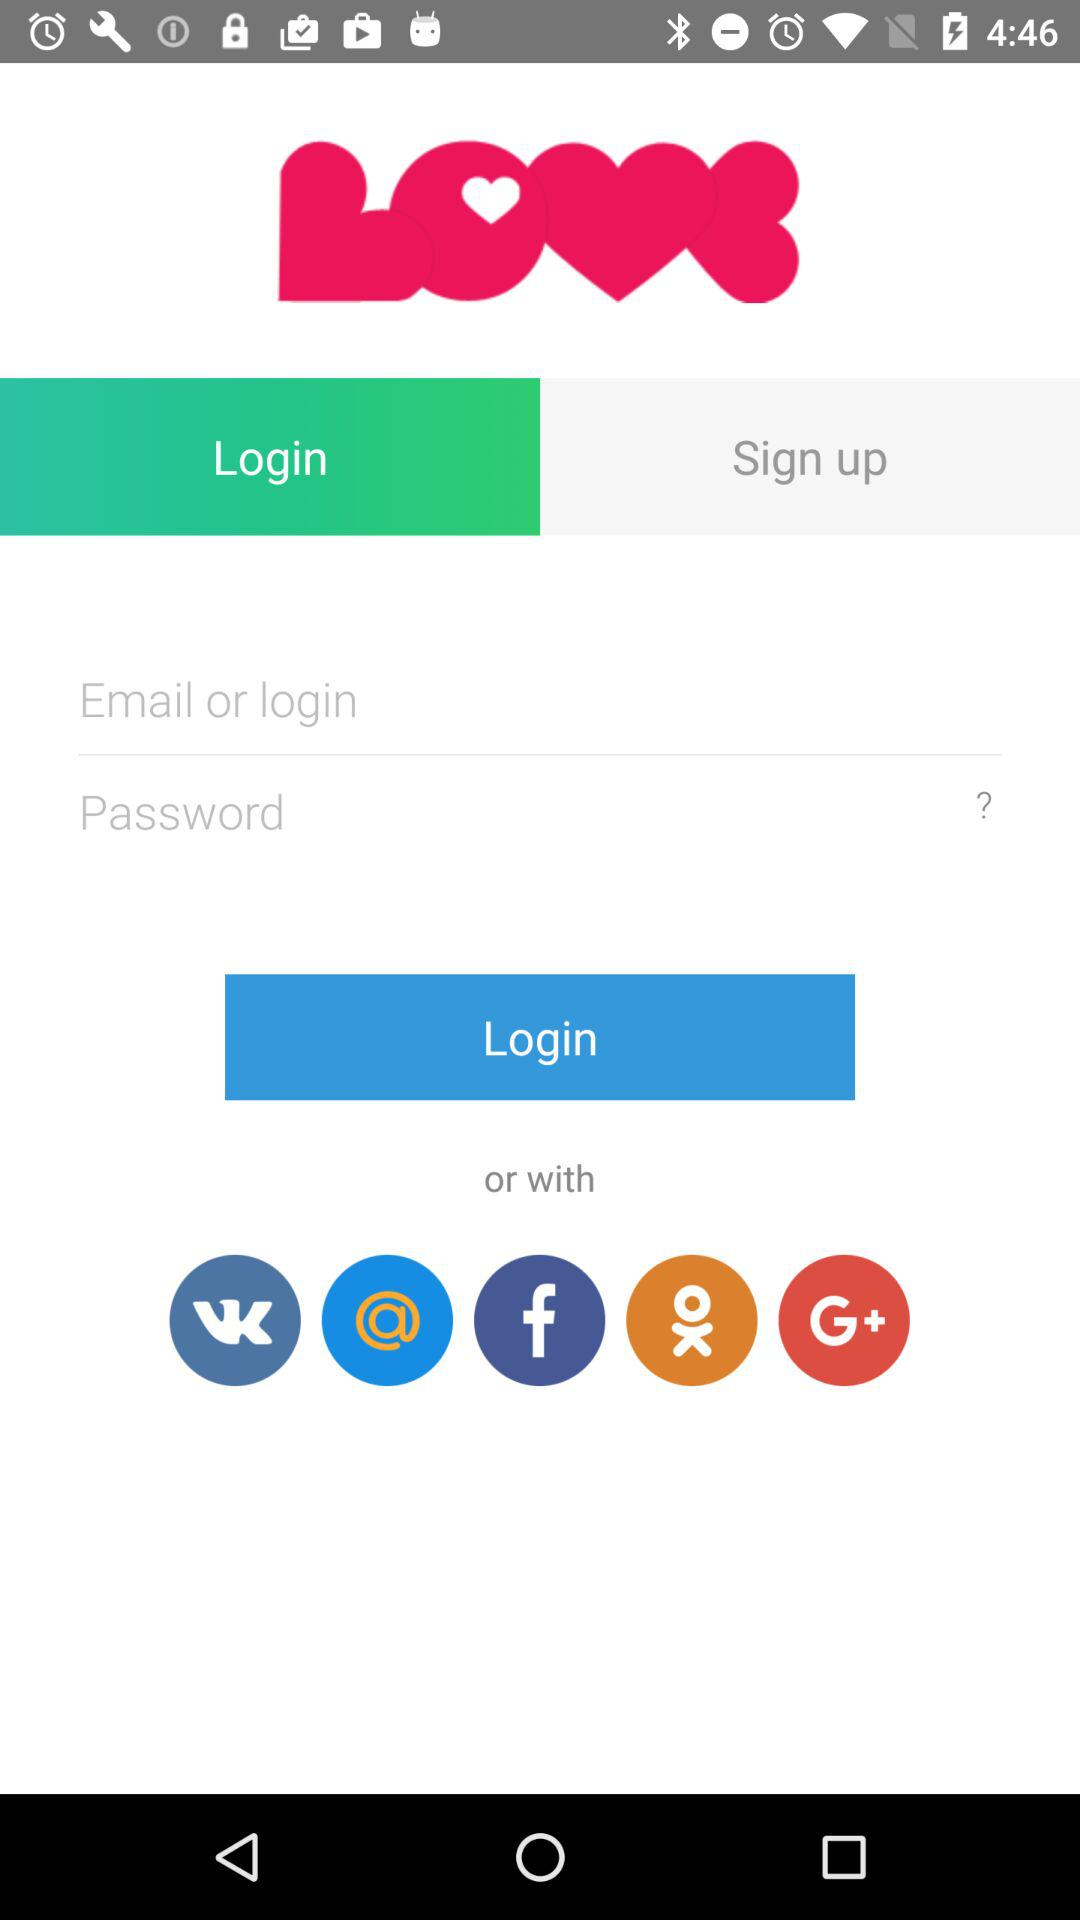Which tab is selected? The selected tab is "Login". 